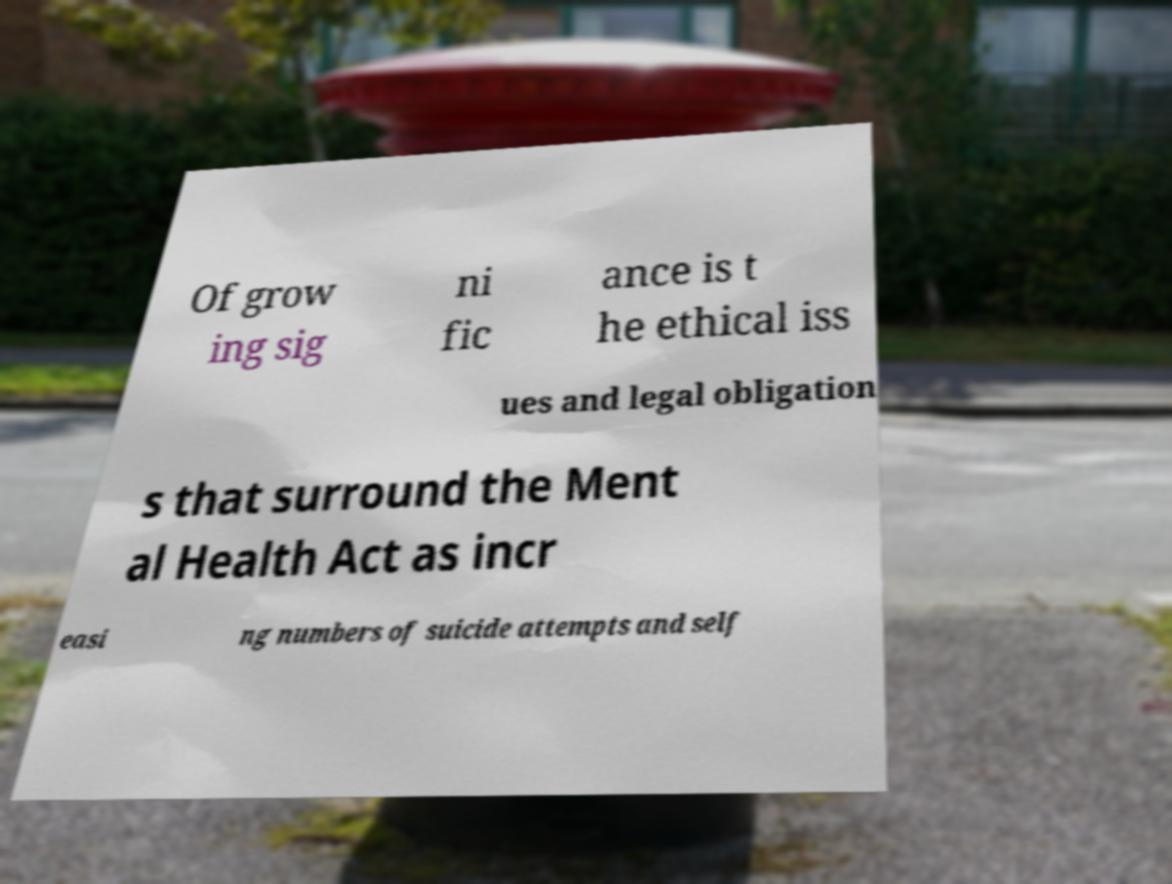Could you assist in decoding the text presented in this image and type it out clearly? Of grow ing sig ni fic ance is t he ethical iss ues and legal obligation s that surround the Ment al Health Act as incr easi ng numbers of suicide attempts and self 